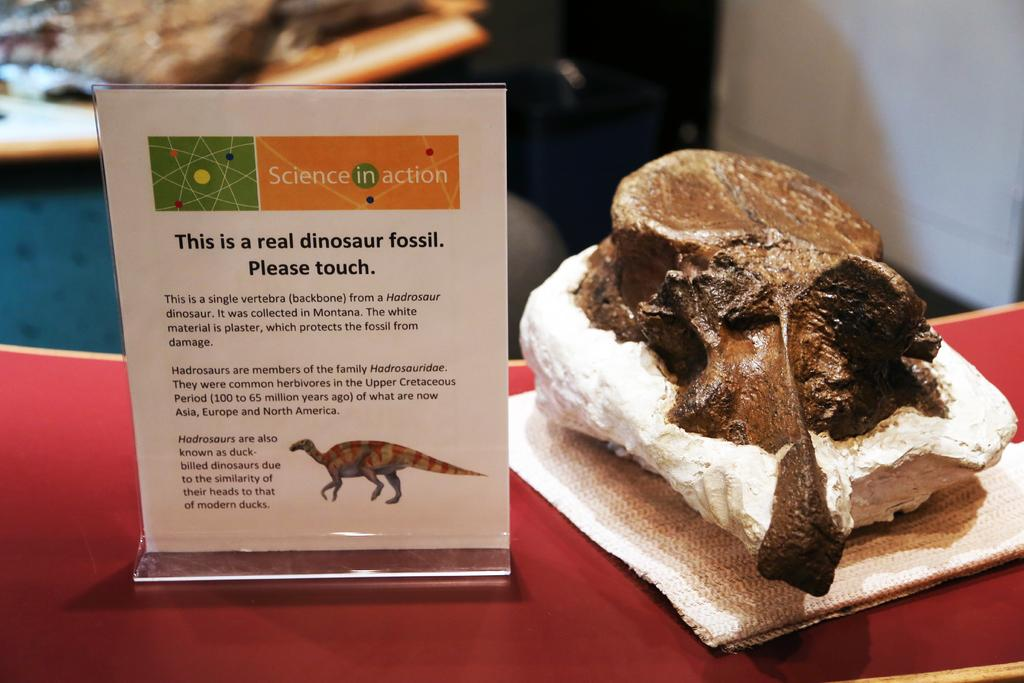What is present in the image that has text on it? There is a tag in the image with text on it. What type of material is visible in the image? There is cloth in the image. What object is placed on a red surface? There is an object on a red surface, but the specific object is not mentioned in the facts. What type of furniture can be seen at the top of the image? There is a cupboard at the top of the image. How would you describe the background of the image? The background of the image is blurred. Is there a maid in the image holding a knife? There is no mention of a maid or a knife in the image, so we cannot confirm their presence. 